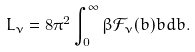Convert formula to latex. <formula><loc_0><loc_0><loc_500><loc_500>L _ { \nu } = 8 \pi ^ { 2 } \int _ { 0 } ^ { \infty } \beta \mathcal { F } _ { \nu } ( b ) b d b .</formula> 